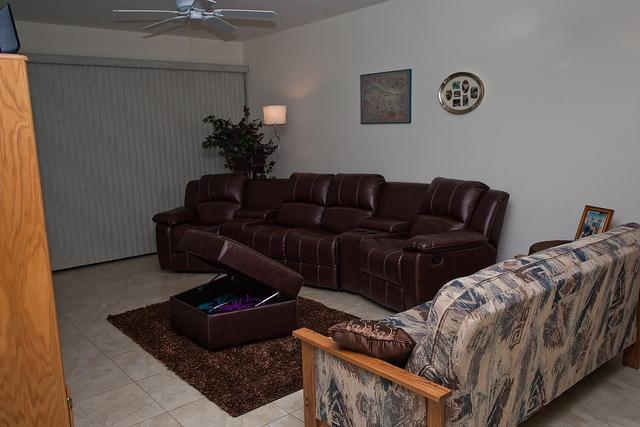How many rugs are shown?
Give a very brief answer. 1. How many couches are in the picture?
Give a very brief answer. 2. 